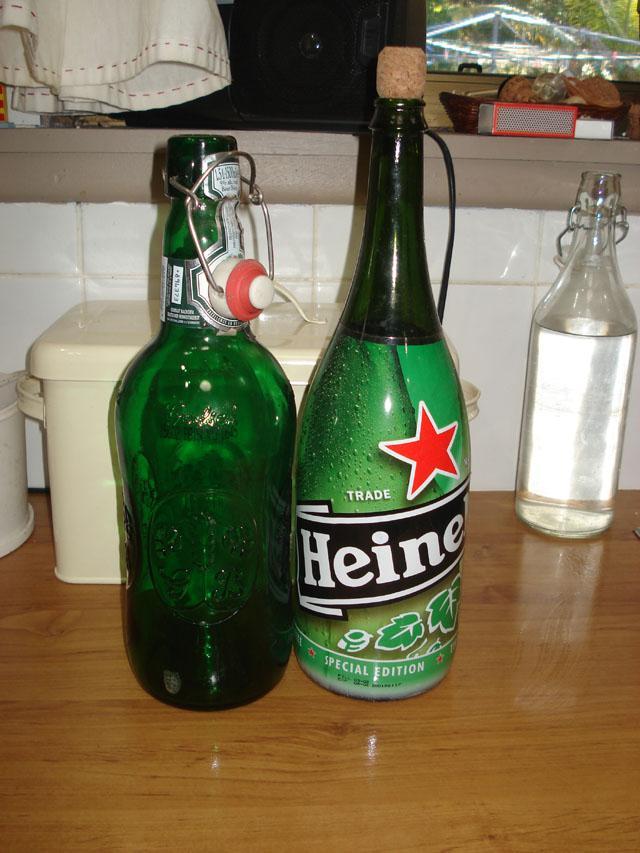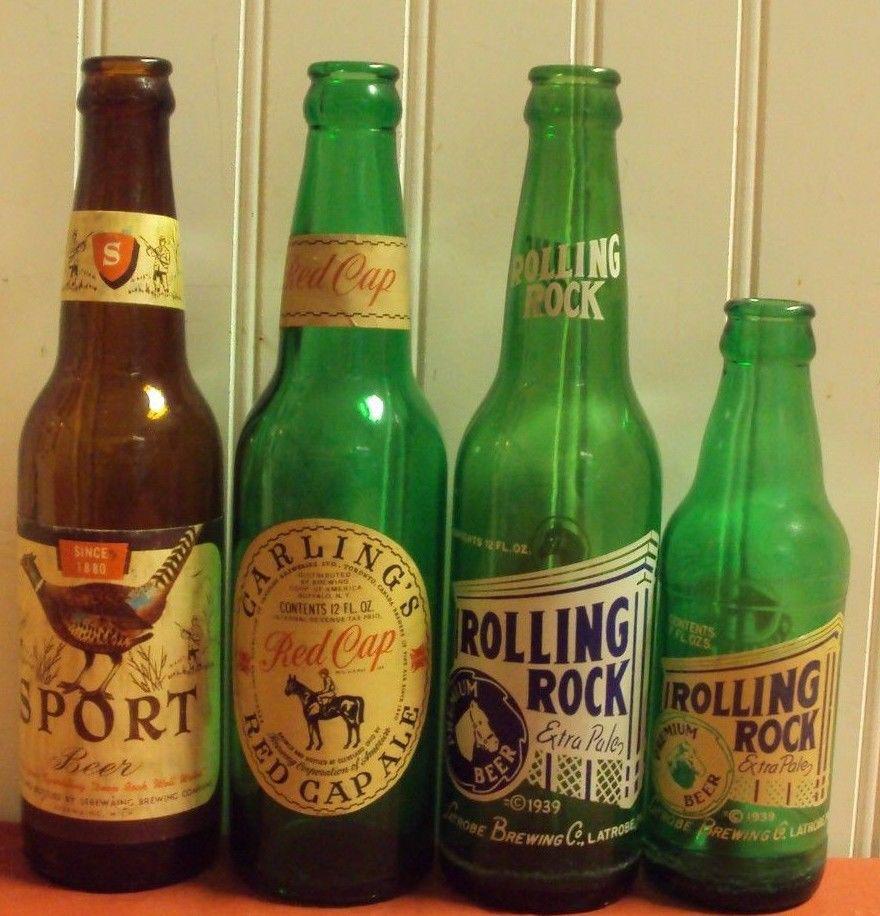The first image is the image on the left, the second image is the image on the right. Given the left and right images, does the statement "An image contains exactly two bottles, both green and the same height." hold true? Answer yes or no. No. The first image is the image on the left, the second image is the image on the right. Examine the images to the left and right. Is the description "The image on the right shows two green glass bottles" accurate? Answer yes or no. No. 